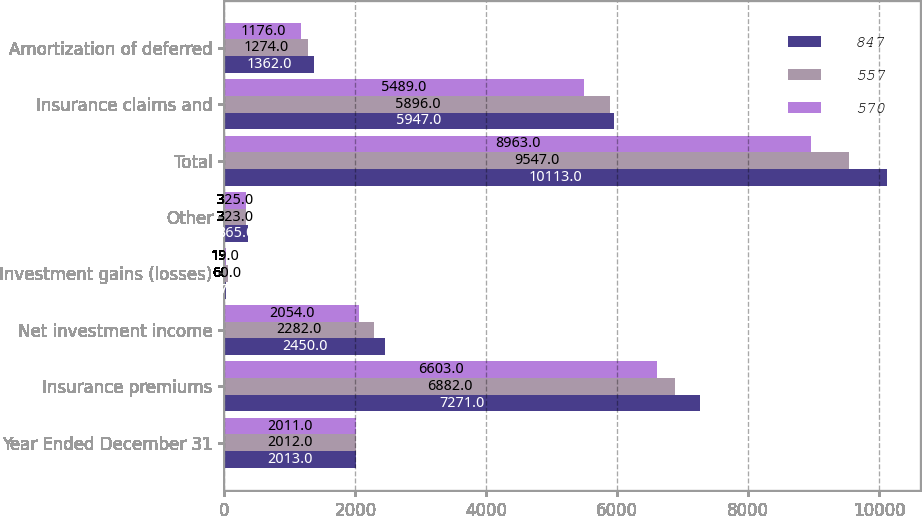Convert chart to OTSL. <chart><loc_0><loc_0><loc_500><loc_500><stacked_bar_chart><ecel><fcel>Year Ended December 31<fcel>Insurance premiums<fcel>Net investment income<fcel>Investment gains (losses)<fcel>Other<fcel>Total<fcel>Insurance claims and<fcel>Amortization of deferred<nl><fcel>847<fcel>2013<fcel>7271<fcel>2450<fcel>27<fcel>365<fcel>10113<fcel>5947<fcel>1362<nl><fcel>557<fcel>2012<fcel>6882<fcel>2282<fcel>60<fcel>323<fcel>9547<fcel>5896<fcel>1274<nl><fcel>570<fcel>2011<fcel>6603<fcel>2054<fcel>19<fcel>325<fcel>8963<fcel>5489<fcel>1176<nl></chart> 